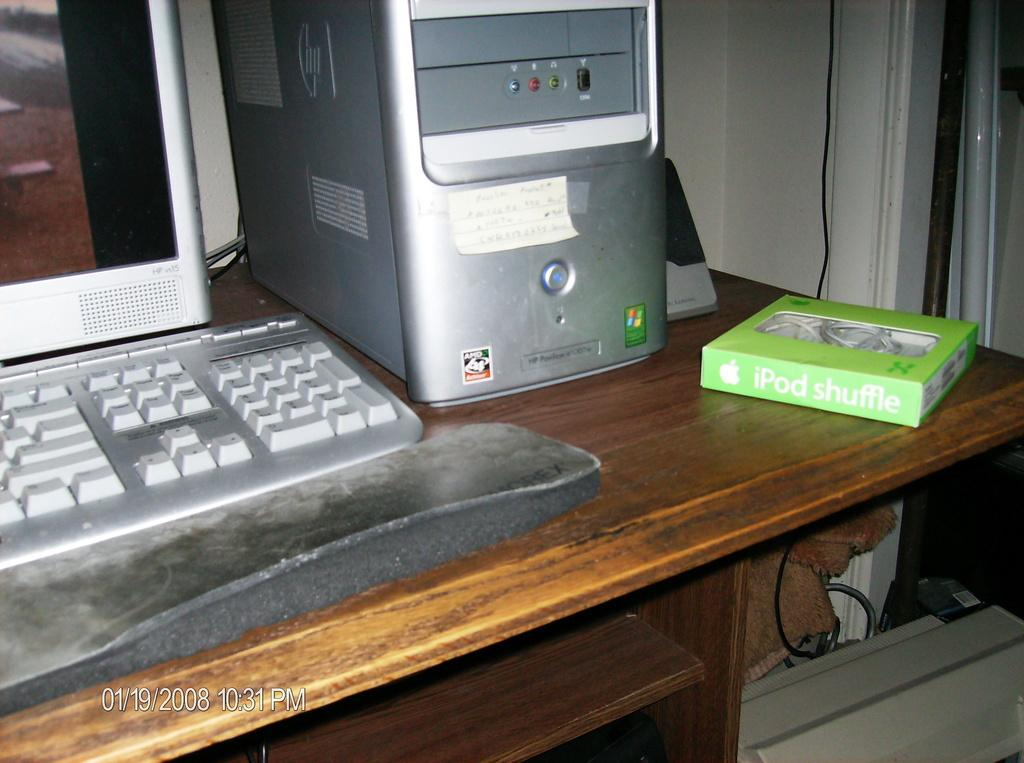<image>
Present a compact description of the photo's key features. An HP Pavillion computer is sitting on a desk. 